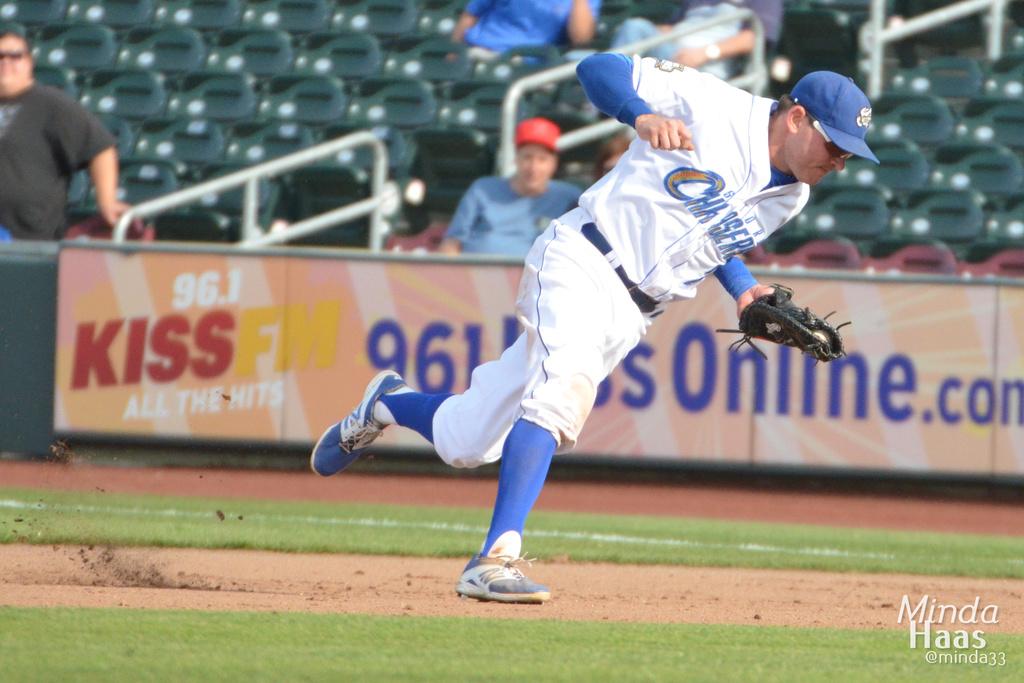What radio station sponsors this stadium?
Ensure brevity in your answer.  Kiss fm. What website is on the ad?
Your answer should be very brief. 961kissonline.com. 